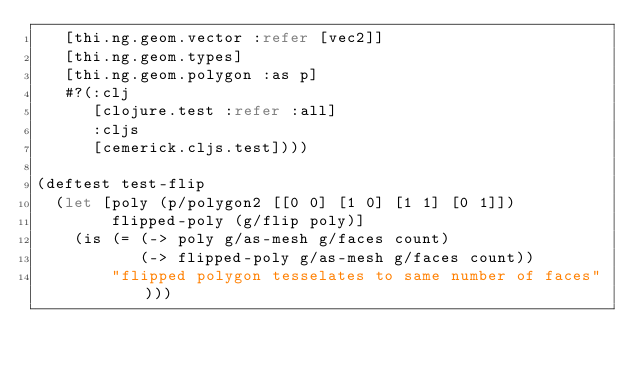<code> <loc_0><loc_0><loc_500><loc_500><_Clojure_>   [thi.ng.geom.vector :refer [vec2]]
   [thi.ng.geom.types]
   [thi.ng.geom.polygon :as p]
   #?(:clj
      [clojure.test :refer :all]
      :cljs
      [cemerick.cljs.test])))

(deftest test-flip
  (let [poly (p/polygon2 [[0 0] [1 0] [1 1] [0 1]])
        flipped-poly (g/flip poly)]
    (is (= (-> poly g/as-mesh g/faces count)
           (-> flipped-poly g/as-mesh g/faces count))
        "flipped polygon tesselates to same number of faces")))
</code> 